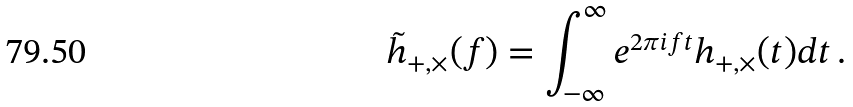<formula> <loc_0><loc_0><loc_500><loc_500>\tilde { h } _ { + , \times } ( f ) = \int _ { - \infty } ^ { \infty } e ^ { 2 \pi i f t } h _ { + , \times } ( t ) d t \, .</formula> 